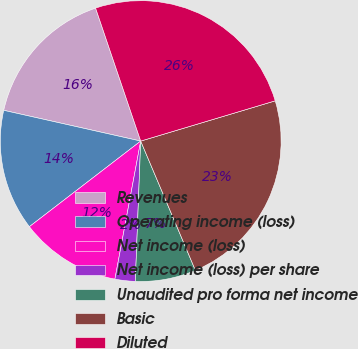Convert chart. <chart><loc_0><loc_0><loc_500><loc_500><pie_chart><fcel>Revenues<fcel>Operating income (loss)<fcel>Net income (loss)<fcel>Net income (loss) per share<fcel>Unaudited pro forma net income<fcel>Basic<fcel>Diluted<nl><fcel>16.28%<fcel>13.95%<fcel>11.63%<fcel>2.33%<fcel>6.98%<fcel>23.26%<fcel>25.58%<nl></chart> 